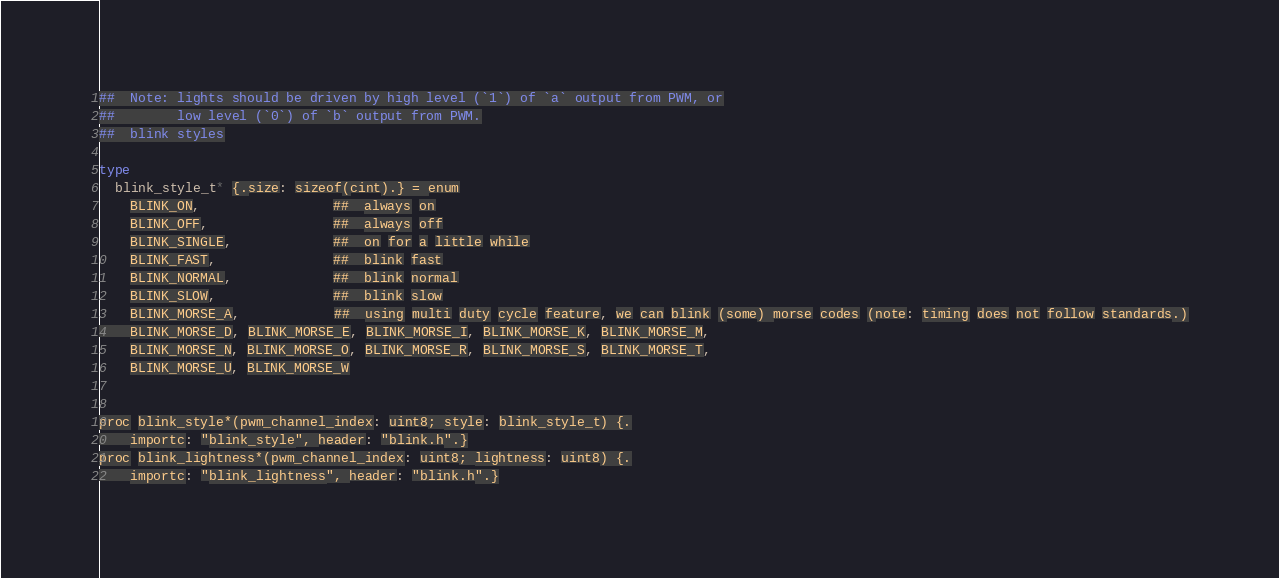Convert code to text. <code><loc_0><loc_0><loc_500><loc_500><_Nim_>##  Note: lights should be driven by high level (`1`) of `a` output from PWM, or
##        low level (`0`) of `b` output from PWM.
##  blink styles

type
  blink_style_t* {.size: sizeof(cint).} = enum
    BLINK_ON,                 ##  always on
    BLINK_OFF,                ##  always off
    BLINK_SINGLE,             ##  on for a little while
    BLINK_FAST,               ##  blink fast
    BLINK_NORMAL,             ##  blink normal
    BLINK_SLOW,               ##  blink slow
    BLINK_MORSE_A,            ##  using multi duty cycle feature, we can blink (some) morse codes (note: timing does not follow standards.)
    BLINK_MORSE_D, BLINK_MORSE_E, BLINK_MORSE_I, BLINK_MORSE_K, BLINK_MORSE_M,
    BLINK_MORSE_N, BLINK_MORSE_O, BLINK_MORSE_R, BLINK_MORSE_S, BLINK_MORSE_T,
    BLINK_MORSE_U, BLINK_MORSE_W


proc blink_style*(pwm_channel_index: uint8; style: blink_style_t) {.
    importc: "blink_style", header: "blink.h".}
proc blink_lightness*(pwm_channel_index: uint8; lightness: uint8) {.
    importc: "blink_lightness", header: "blink.h".}</code> 